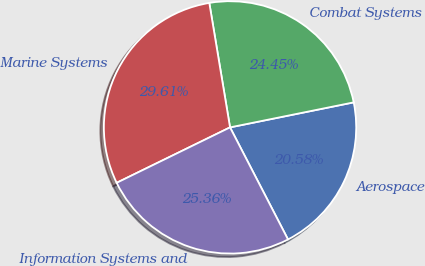<chart> <loc_0><loc_0><loc_500><loc_500><pie_chart><fcel>Aerospace<fcel>Combat Systems<fcel>Marine Systems<fcel>Information Systems and<nl><fcel>20.58%<fcel>24.45%<fcel>29.61%<fcel>25.36%<nl></chart> 